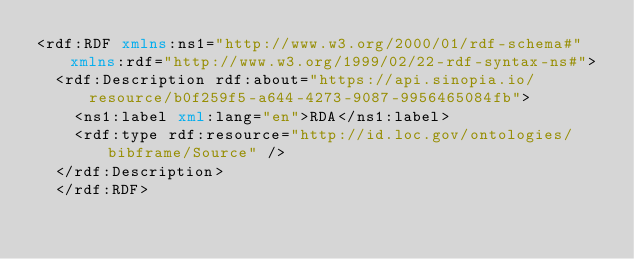Convert code to text. <code><loc_0><loc_0><loc_500><loc_500><_XML_><rdf:RDF xmlns:ns1="http://www.w3.org/2000/01/rdf-schema#" xmlns:rdf="http://www.w3.org/1999/02/22-rdf-syntax-ns#">
  <rdf:Description rdf:about="https://api.sinopia.io/resource/b0f259f5-a644-4273-9087-9956465084fb">
    <ns1:label xml:lang="en">RDA</ns1:label>
    <rdf:type rdf:resource="http://id.loc.gov/ontologies/bibframe/Source" />
  </rdf:Description>
  </rdf:RDF></code> 